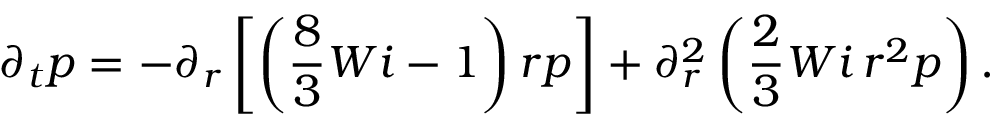<formula> <loc_0><loc_0><loc_500><loc_500>\partial _ { t } p = - \partial _ { r } \left [ \left ( \frac { 8 } { 3 } W i - 1 \right ) r p \right ] + \partial _ { r } ^ { 2 } \left ( \frac { 2 } { 3 } W i \, r ^ { 2 } p \right ) .</formula> 